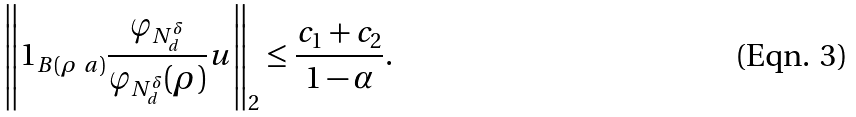<formula> <loc_0><loc_0><loc_500><loc_500>\left \| 1 _ { B ( \rho \ a ) } \frac { \varphi _ { N _ { d } ^ { \delta } } } { \varphi _ { N _ { d } ^ { \delta } } ( \rho ) } u \right \| _ { 2 } \leq \frac { c _ { 1 } + c _ { 2 } } { 1 - \alpha } .</formula> 